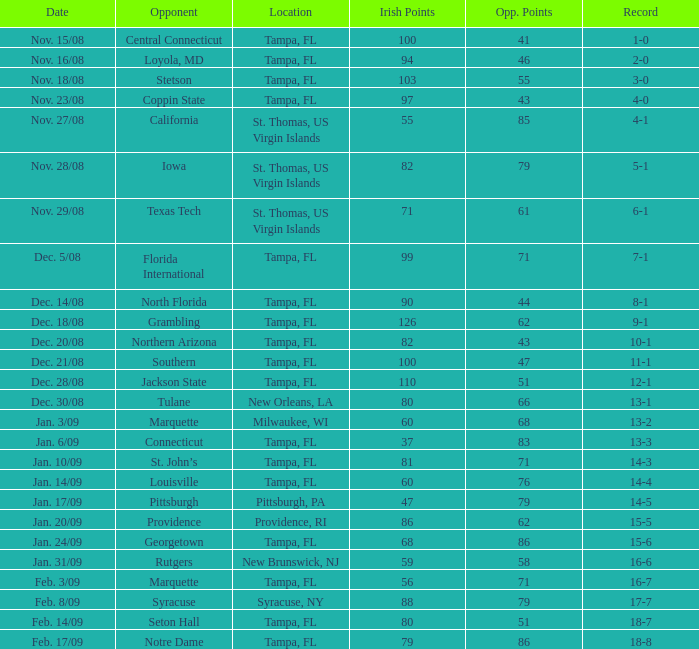In syracuse, ny, what is the quantity of opposition? 1.0. 